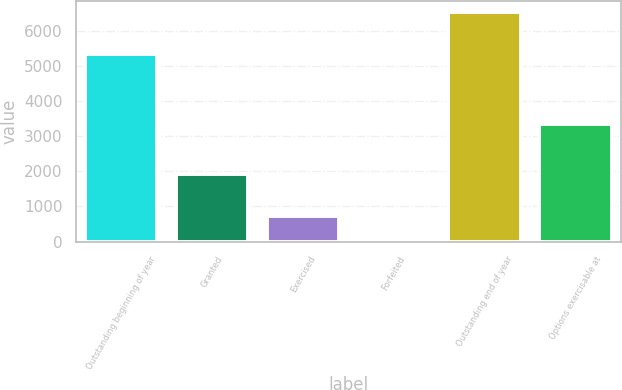Convert chart to OTSL. <chart><loc_0><loc_0><loc_500><loc_500><bar_chart><fcel>Outstanding beginning of year<fcel>Granted<fcel>Exercised<fcel>Forfeited<fcel>Outstanding end of year<fcel>Options exercisable at<nl><fcel>5358<fcel>1933<fcel>720.5<fcel>74<fcel>6539<fcel>3338<nl></chart> 